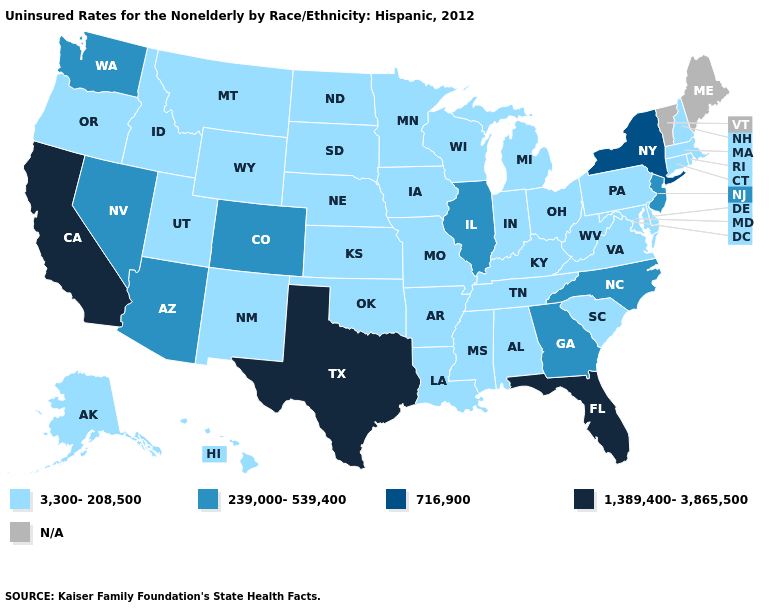Does Texas have the highest value in the USA?
Short answer required. Yes. What is the value of Illinois?
Concise answer only. 239,000-539,400. What is the lowest value in states that border Tennessee?
Answer briefly. 3,300-208,500. Which states have the highest value in the USA?
Concise answer only. California, Florida, Texas. Does Wyoming have the highest value in the USA?
Quick response, please. No. Does Illinois have the lowest value in the MidWest?
Answer briefly. No. Name the states that have a value in the range 3,300-208,500?
Write a very short answer. Alabama, Alaska, Arkansas, Connecticut, Delaware, Hawaii, Idaho, Indiana, Iowa, Kansas, Kentucky, Louisiana, Maryland, Massachusetts, Michigan, Minnesota, Mississippi, Missouri, Montana, Nebraska, New Hampshire, New Mexico, North Dakota, Ohio, Oklahoma, Oregon, Pennsylvania, Rhode Island, South Carolina, South Dakota, Tennessee, Utah, Virginia, West Virginia, Wisconsin, Wyoming. Does Illinois have the highest value in the USA?
Quick response, please. No. Does Kentucky have the lowest value in the USA?
Quick response, please. Yes. What is the value of Idaho?
Write a very short answer. 3,300-208,500. Is the legend a continuous bar?
Keep it brief. No. Which states have the lowest value in the USA?
Answer briefly. Alabama, Alaska, Arkansas, Connecticut, Delaware, Hawaii, Idaho, Indiana, Iowa, Kansas, Kentucky, Louisiana, Maryland, Massachusetts, Michigan, Minnesota, Mississippi, Missouri, Montana, Nebraska, New Hampshire, New Mexico, North Dakota, Ohio, Oklahoma, Oregon, Pennsylvania, Rhode Island, South Carolina, South Dakota, Tennessee, Utah, Virginia, West Virginia, Wisconsin, Wyoming. What is the value of Georgia?
Short answer required. 239,000-539,400. Which states hav the highest value in the West?
Answer briefly. California. Name the states that have a value in the range 1,389,400-3,865,500?
Short answer required. California, Florida, Texas. 